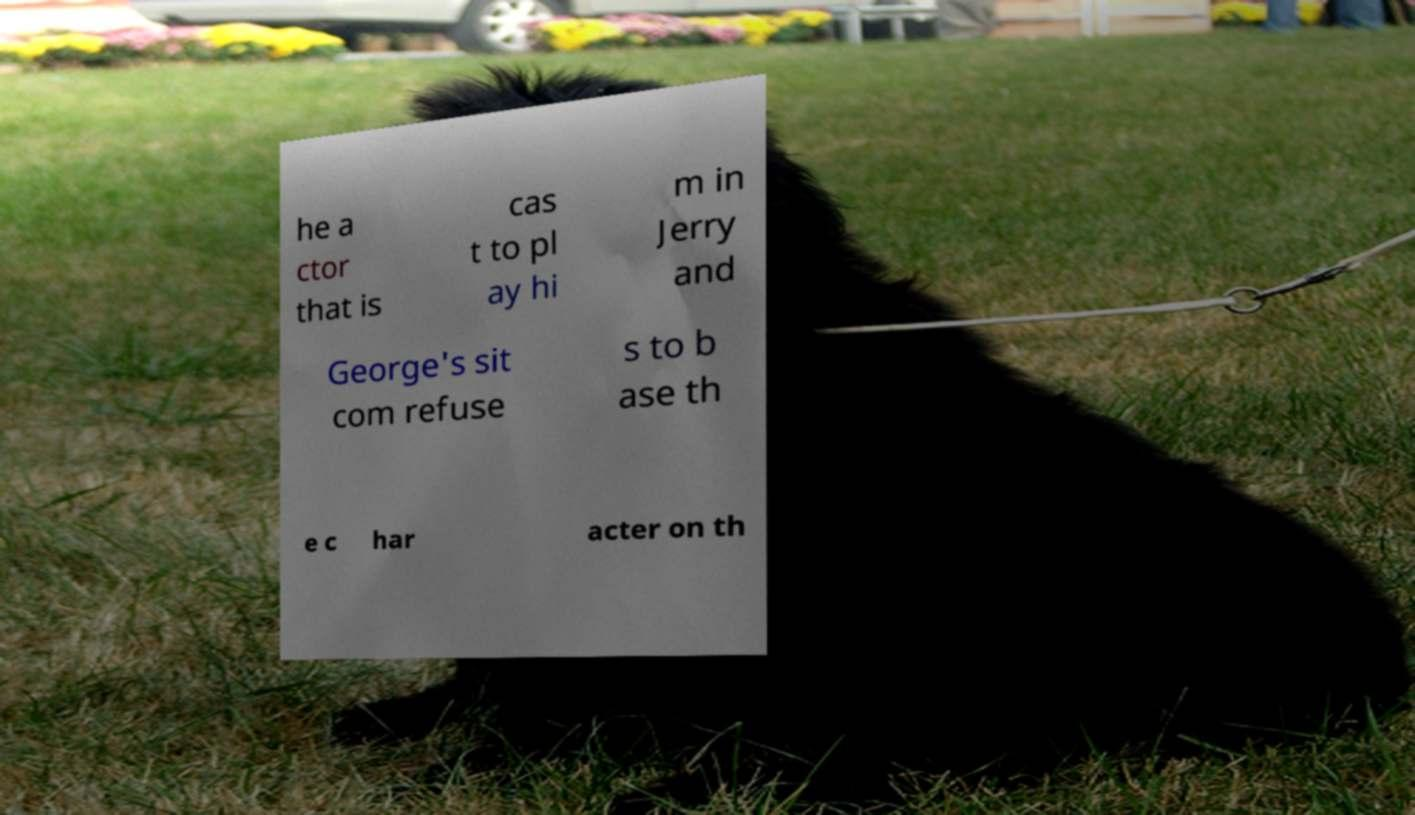Please read and relay the text visible in this image. What does it say? he a ctor that is cas t to pl ay hi m in Jerry and George's sit com refuse s to b ase th e c har acter on th 